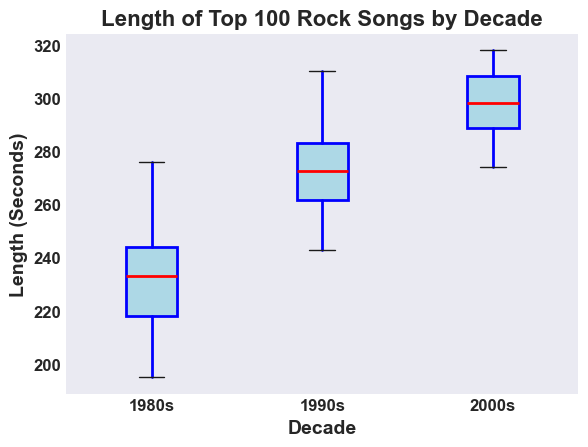What's the median length of the top 100 rock songs from the 1980s? To find the median, look at the center value of the “1980s” box. The red line inside the box represents the median.
Answer: 233 Which decade has the longest average song length, the 1990s or the 2000s? The average song length can be approximated by looking at the middle of the box. The box for the 2000s is positioned higher on the y-axis than the box for the 1990s.
Answer: 2000s What is the interquartile range (IQR) of the song lengths for the 1990s? IQR is the difference between the third quartile (top boundary of the box) and the first quartile (bottom boundary of the box). For the 1990s, the boundaries are approximately 272 and 260. Subtract 260 from 272.
Answer: 12 Which decade has the smallest range of song lengths, and what is that range? The range is the difference between the maximum and minimum values (whiskers) for each box. The 1980s have the smallest range. Subtract the minimum (195) from the maximum (276).
Answer: 1980s, 81 Do any decades have outliers in their song lengths? Outliers are represented as points outside the whiskers. All the decades (1980s, 1990s, 2000s) have outliers visible.
Answer: Yes How does the median song length of the 1980s compare to the median song length of the 2000s? Compare the position of the red median lines inside the boxes for each decade. The median for the 2000s is higher than the median for the 1980s.
Answer: The 2000s are longer Are there more variations in song lengths in the 2000s compared to the 1980s? Variability can be seen by the height of the boxes and the length of the whiskers. The box and whiskers for the 2000s are longer than those for the 1980s.
Answer: Yes What is the maximum song length observed in the 1990s? The top whisker extends to the maximum value for the 1990s. It goes up to almost 310 seconds.
Answer: 310 Calculate the difference between the median song lengths of the 1990s and the 2000s. Check the red median line in the box for each decade. The 1990s median is around 270 seconds, and the 2000s median is around 298. Subtract 270 from 298.
Answer: 28 Is the range of the song lengths wider in the 1980s or the 2000s? Compare the length from the bottom to the top whisker for the 1980s and 2000s. The 2000s have a wider range.
Answer: 2000s 